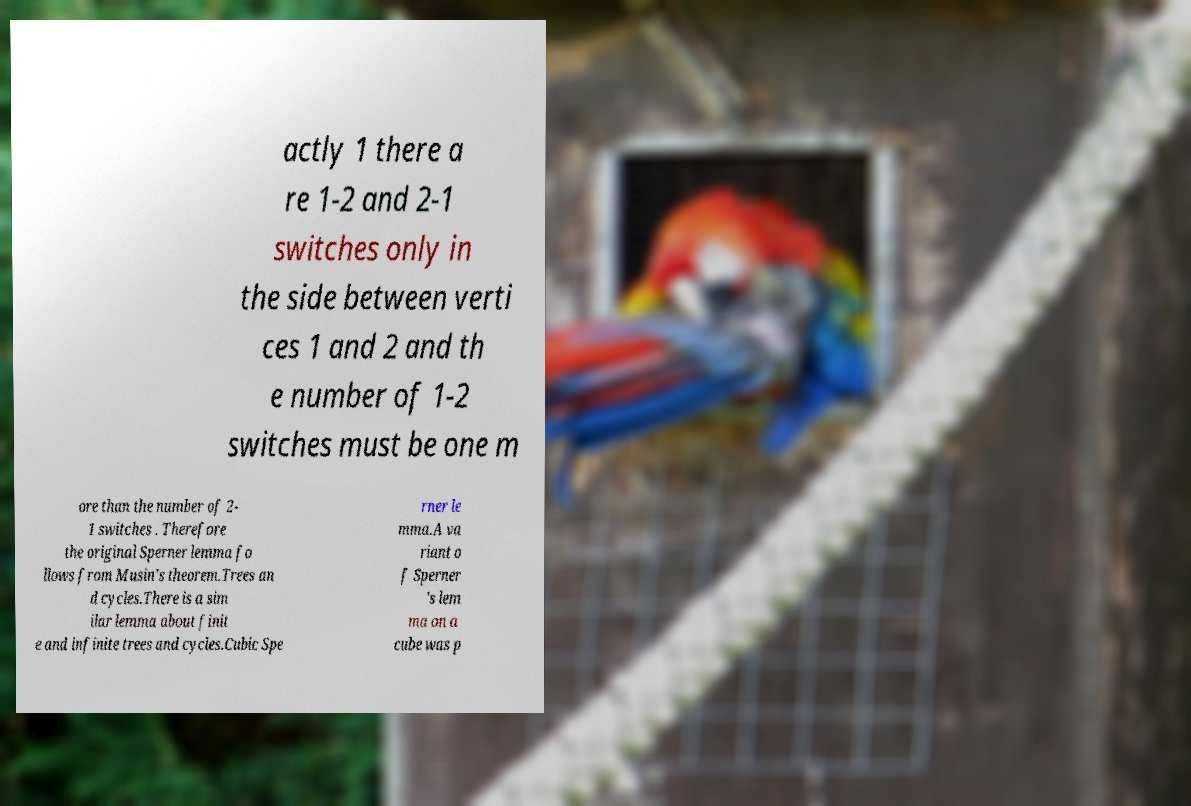I need the written content from this picture converted into text. Can you do that? actly 1 there a re 1-2 and 2-1 switches only in the side between verti ces 1 and 2 and th e number of 1-2 switches must be one m ore than the number of 2- 1 switches . Therefore the original Sperner lemma fo llows from Musin's theorem.Trees an d cycles.There is a sim ilar lemma about finit e and infinite trees and cycles.Cubic Spe rner le mma.A va riant o f Sperner 's lem ma on a cube was p 